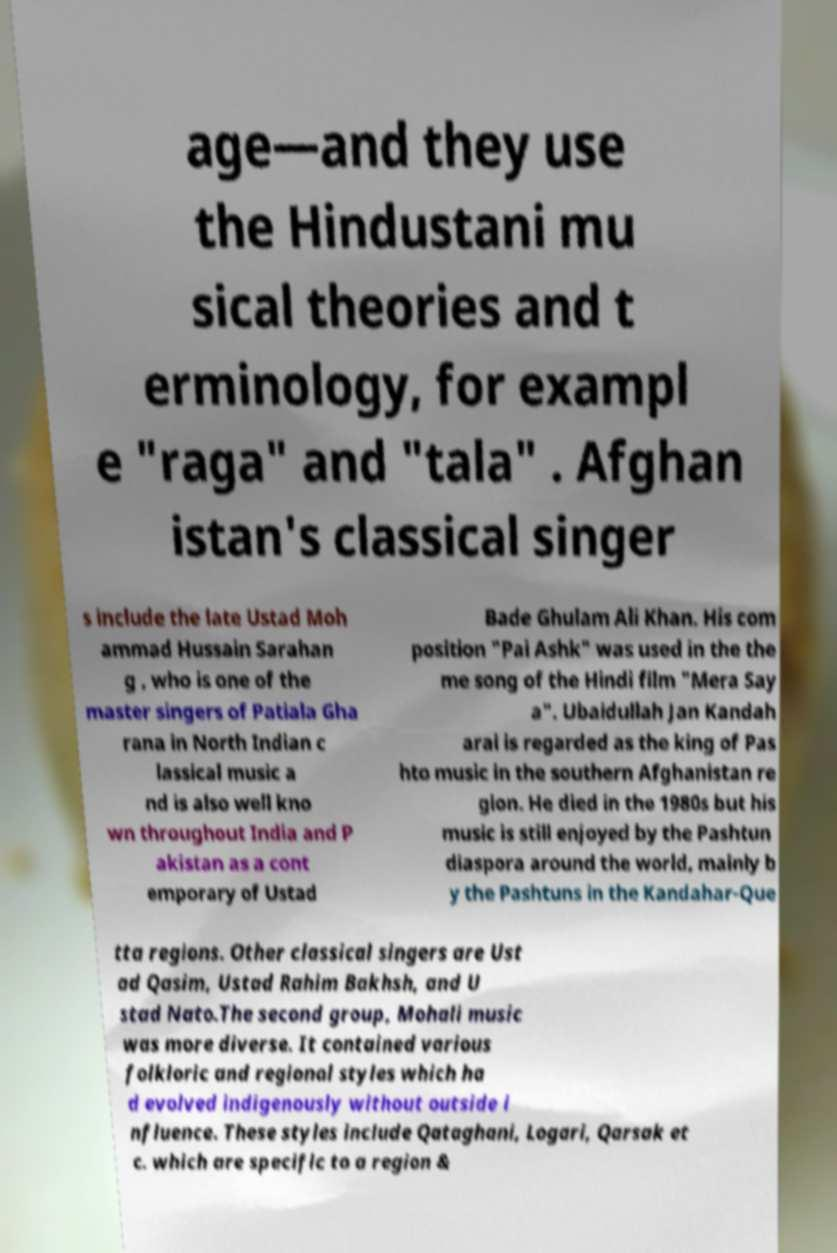Can you read and provide the text displayed in the image?This photo seems to have some interesting text. Can you extract and type it out for me? age—and they use the Hindustani mu sical theories and t erminology, for exampl e "raga" and "tala" . Afghan istan's classical singer s include the late Ustad Moh ammad Hussain Sarahan g , who is one of the master singers of Patiala Gha rana in North Indian c lassical music a nd is also well kno wn throughout India and P akistan as a cont emporary of Ustad Bade Ghulam Ali Khan. His com position "Pai Ashk" was used in the the me song of the Hindi film "Mera Say a". Ubaidullah Jan Kandah arai is regarded as the king of Pas hto music in the southern Afghanistan re gion. He died in the 1980s but his music is still enjoyed by the Pashtun diaspora around the world, mainly b y the Pashtuns in the Kandahar-Que tta regions. Other classical singers are Ust ad Qasim, Ustad Rahim Bakhsh, and U stad Nato.The second group, Mohali music was more diverse. It contained various folkloric and regional styles which ha d evolved indigenously without outside i nfluence. These styles include Qataghani, Logari, Qarsak et c. which are specific to a region & 